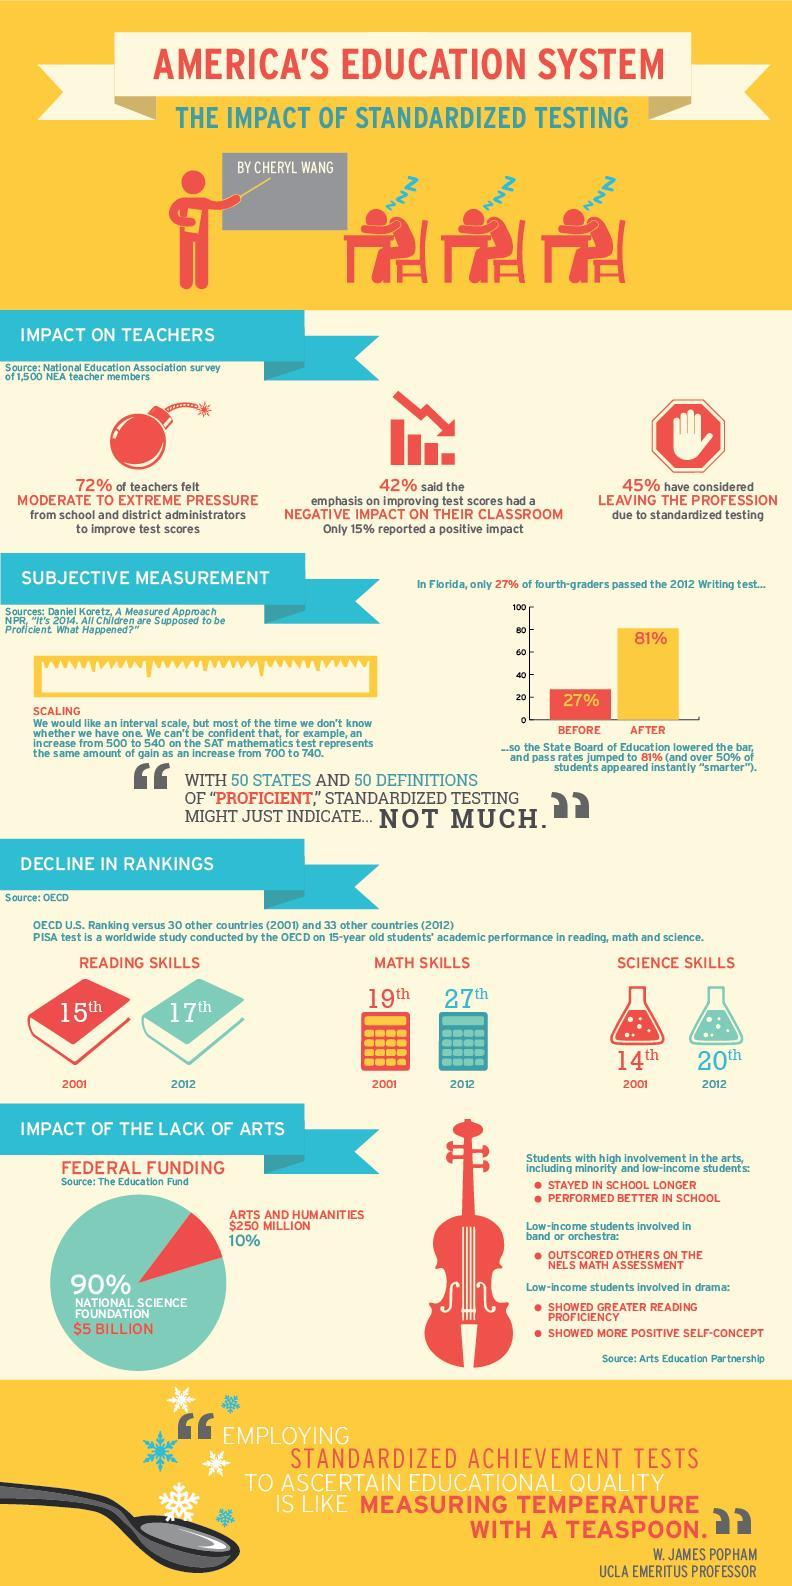What is the OECD U.S ranking in science skills over 33 other countries in 2012?
Answer the question with a short phrase. 20th How much is the federal funding for Arts & Humanities? $250 MILLLION What is the OECD U.S ranking in maths skills over 30 other countries in 2001? 19th How much is the federal funding for National Science Foundation? $5 BILLION 